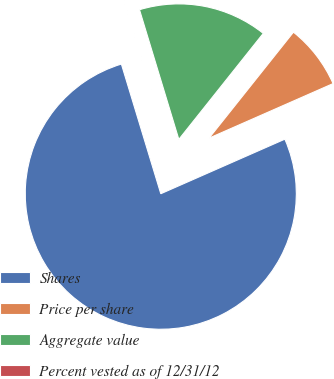<chart> <loc_0><loc_0><loc_500><loc_500><pie_chart><fcel>Shares<fcel>Price per share<fcel>Aggregate value<fcel>Percent vested as of 12/31/12<nl><fcel>76.9%<fcel>7.7%<fcel>15.39%<fcel>0.01%<nl></chart> 